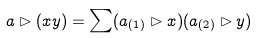Convert formula to latex. <formula><loc_0><loc_0><loc_500><loc_500>a \rhd ( x y ) = \sum ( a _ { ( 1 ) } \rhd x ) ( a _ { ( 2 ) } \rhd y )</formula> 